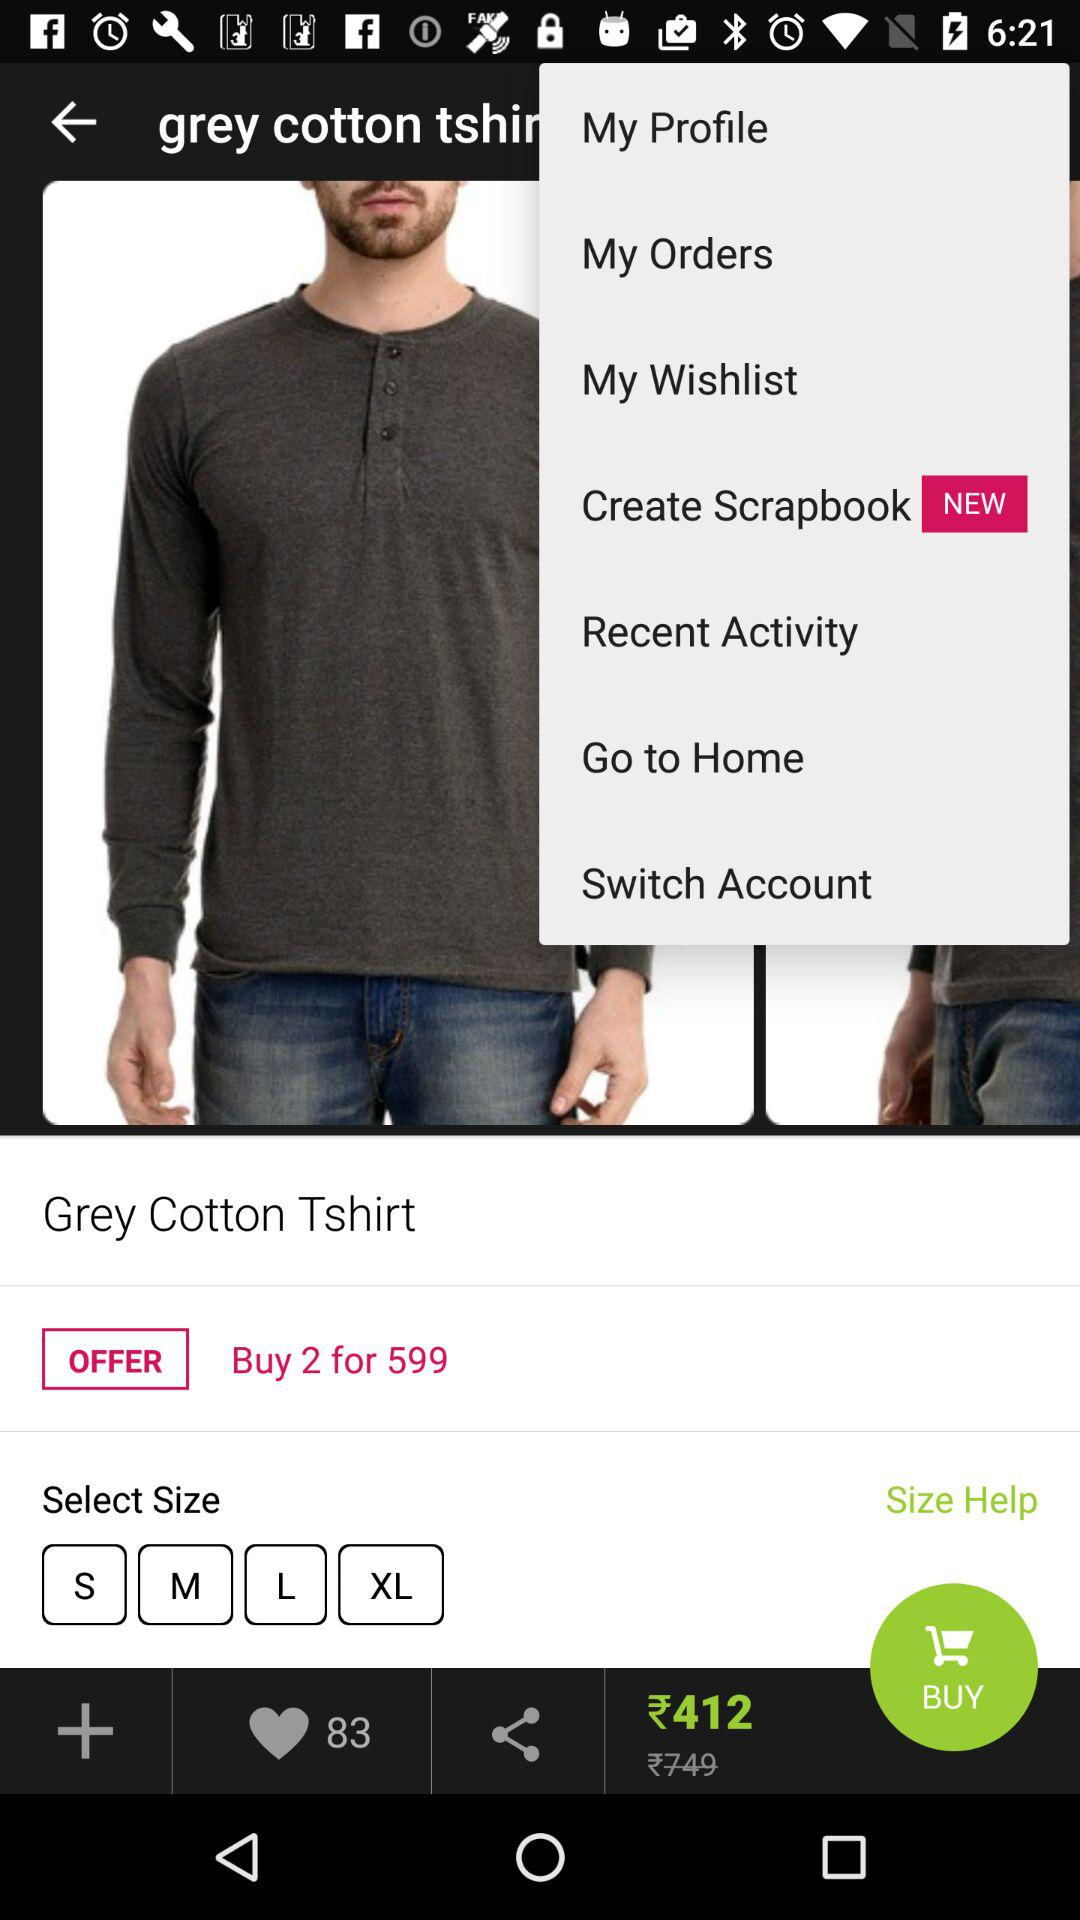What is the discounted price of the "Grey Cotton Tshirt"? The discounted price of the "Grey Cotton Tshirt" is ₹412. 